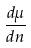Convert formula to latex. <formula><loc_0><loc_0><loc_500><loc_500>\frac { d \mu } { d n }</formula> 